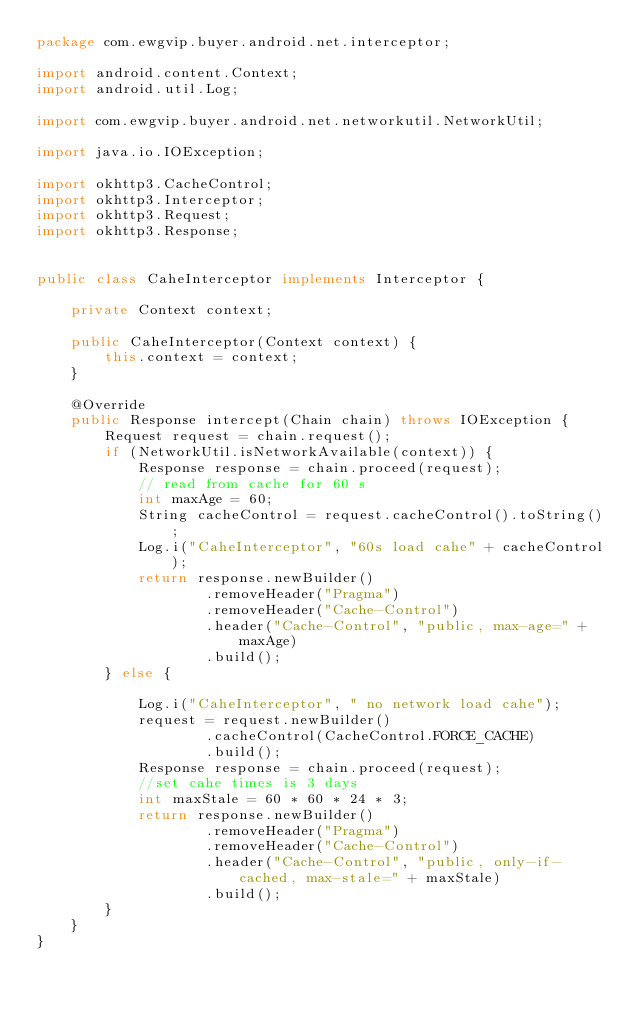Convert code to text. <code><loc_0><loc_0><loc_500><loc_500><_Java_>package com.ewgvip.buyer.android.net.interceptor;

import android.content.Context;
import android.util.Log;

import com.ewgvip.buyer.android.net.networkutil.NetworkUtil;

import java.io.IOException;

import okhttp3.CacheControl;
import okhttp3.Interceptor;
import okhttp3.Request;
import okhttp3.Response;


public class CaheInterceptor implements Interceptor {

    private Context context;

    public CaheInterceptor(Context context) {
        this.context = context;
    }

    @Override
    public Response intercept(Chain chain) throws IOException {
        Request request = chain.request();
        if (NetworkUtil.isNetworkAvailable(context)) {
            Response response = chain.proceed(request);
            // read from cache for 60 s
            int maxAge = 60;
            String cacheControl = request.cacheControl().toString();
            Log.i("CaheInterceptor", "60s load cahe" + cacheControl);
            return response.newBuilder()
                    .removeHeader("Pragma")
                    .removeHeader("Cache-Control")
                    .header("Cache-Control", "public, max-age=" + maxAge)
                    .build();
        } else {

            Log.i("CaheInterceptor", " no network load cahe");
            request = request.newBuilder()
                    .cacheControl(CacheControl.FORCE_CACHE)
                    .build();
            Response response = chain.proceed(request);
            //set cahe times is 3 days
            int maxStale = 60 * 60 * 24 * 3;
            return response.newBuilder()
                    .removeHeader("Pragma")
                    .removeHeader("Cache-Control")
                    .header("Cache-Control", "public, only-if-cached, max-stale=" + maxStale)
                    .build();
        }
    }
}
</code> 